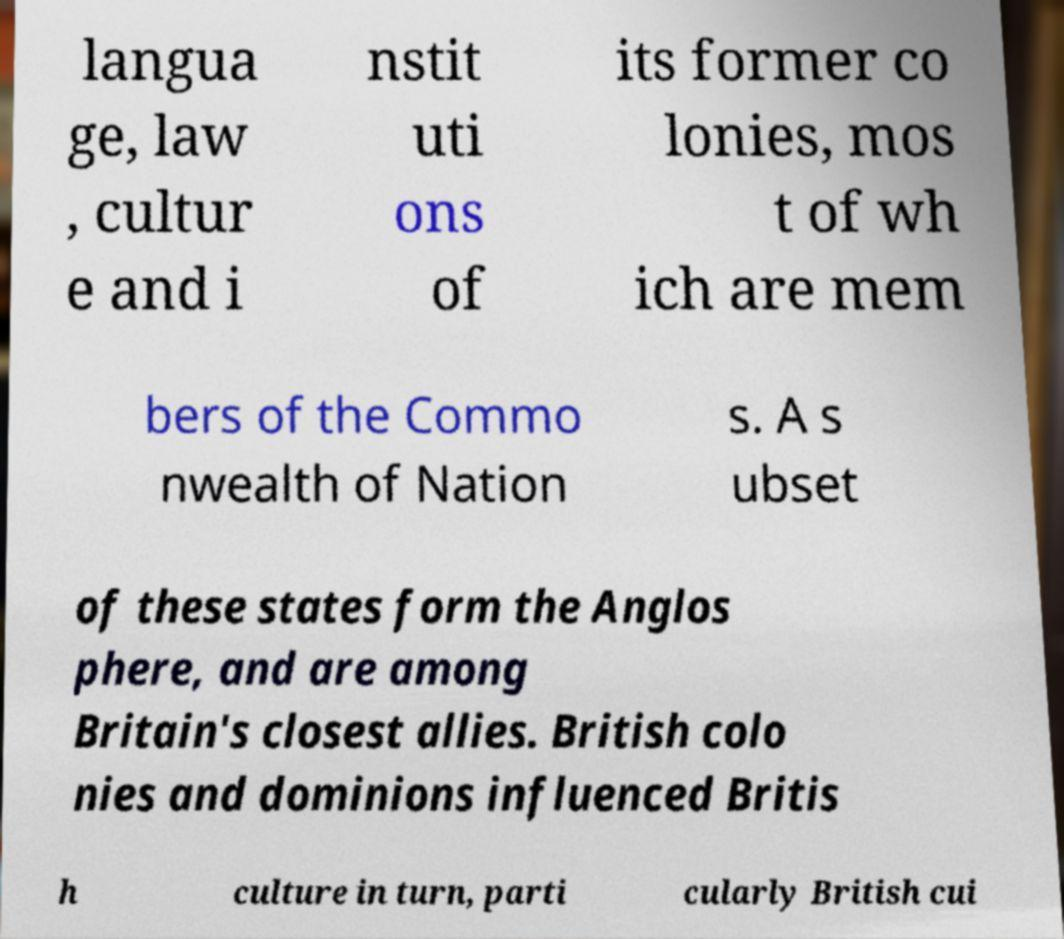Can you accurately transcribe the text from the provided image for me? langua ge, law , cultur e and i nstit uti ons of its former co lonies, mos t of wh ich are mem bers of the Commo nwealth of Nation s. A s ubset of these states form the Anglos phere, and are among Britain's closest allies. British colo nies and dominions influenced Britis h culture in turn, parti cularly British cui 